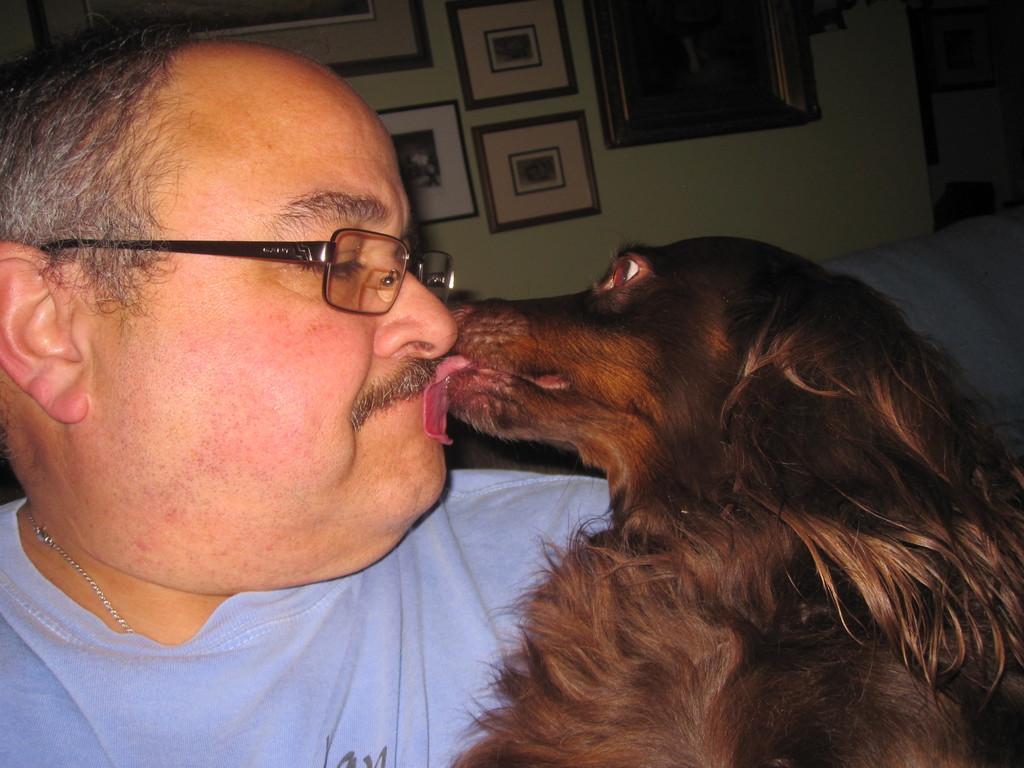How would you summarize this image in a sentence or two? This image is taken indoors. In the background there is a wall with a few picture frames on it. On the left side of the image there is a man. On the right side of the image there is a dog and it is licking the face of a man. 